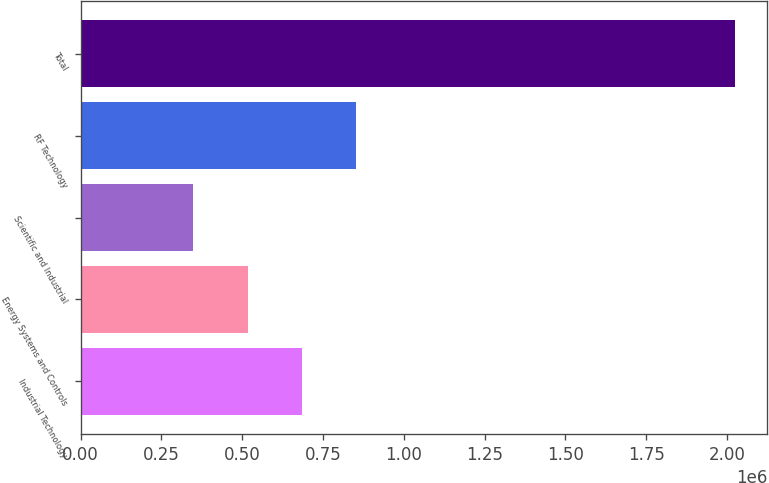<chart> <loc_0><loc_0><loc_500><loc_500><bar_chart><fcel>Industrial Technology<fcel>Energy Systems and Controls<fcel>Scientific and Industrial<fcel>RF Technology<fcel>Total<nl><fcel>684107<fcel>516620<fcel>349132<fcel>851595<fcel>2.02401e+06<nl></chart> 